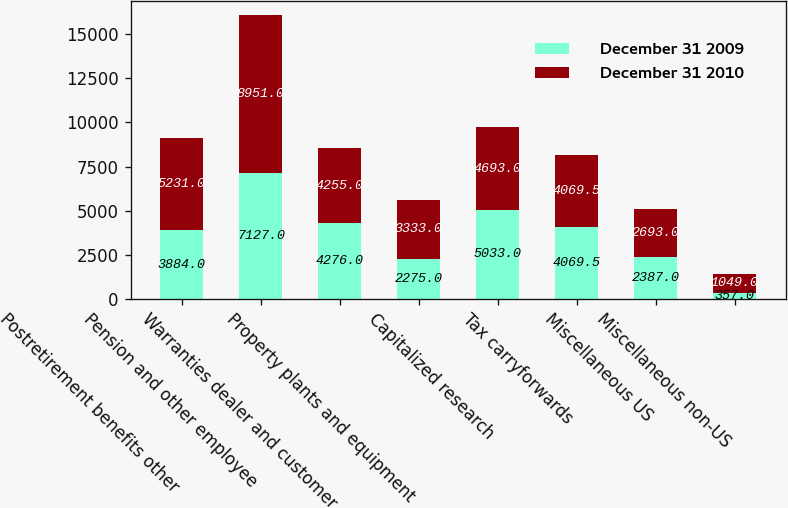Convert chart. <chart><loc_0><loc_0><loc_500><loc_500><stacked_bar_chart><ecel><fcel>Postretirement benefits other<fcel>Pension and other employee<fcel>Warranties dealer and customer<fcel>Property plants and equipment<fcel>Capitalized research<fcel>Tax carryforwards<fcel>Miscellaneous US<fcel>Miscellaneous non-US<nl><fcel>December 31 2009<fcel>3884<fcel>7127<fcel>4276<fcel>2275<fcel>5033<fcel>4069.5<fcel>2387<fcel>357<nl><fcel>December 31 2010<fcel>5231<fcel>8951<fcel>4255<fcel>3333<fcel>4693<fcel>4069.5<fcel>2693<fcel>1049<nl></chart> 